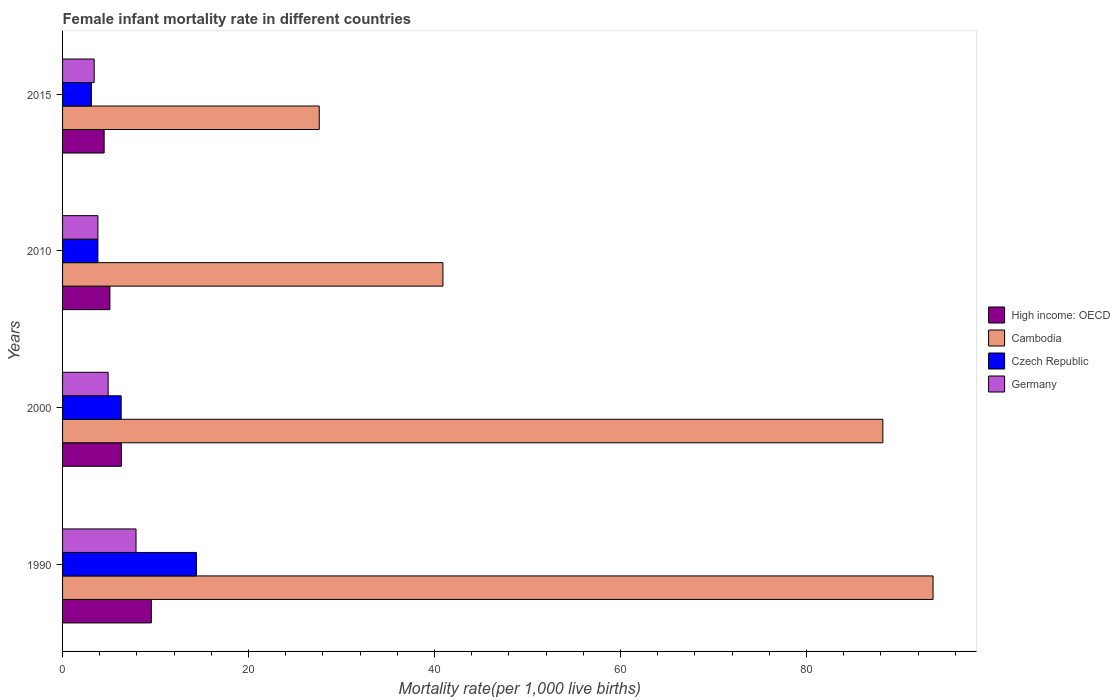How many groups of bars are there?
Your answer should be very brief. 4. Are the number of bars per tick equal to the number of legend labels?
Ensure brevity in your answer.  Yes. How many bars are there on the 4th tick from the top?
Your answer should be very brief. 4. How many bars are there on the 1st tick from the bottom?
Offer a terse response. 4. What is the label of the 1st group of bars from the top?
Provide a short and direct response. 2015. What is the female infant mortality rate in High income: OECD in 1990?
Give a very brief answer. 9.54. Across all years, what is the maximum female infant mortality rate in Cambodia?
Give a very brief answer. 93.6. Across all years, what is the minimum female infant mortality rate in Czech Republic?
Offer a very short reply. 3.1. In which year was the female infant mortality rate in Germany minimum?
Give a very brief answer. 2015. What is the total female infant mortality rate in Germany in the graph?
Give a very brief answer. 20. What is the difference between the female infant mortality rate in Germany in 1990 and that in 2015?
Ensure brevity in your answer.  4.5. What is the difference between the female infant mortality rate in High income: OECD in 2010 and the female infant mortality rate in Germany in 2015?
Your response must be concise. 1.69. What is the average female infant mortality rate in Cambodia per year?
Your answer should be compact. 62.58. In the year 2010, what is the difference between the female infant mortality rate in Cambodia and female infant mortality rate in Czech Republic?
Your answer should be very brief. 37.1. In how many years, is the female infant mortality rate in Czech Republic greater than 92 ?
Your answer should be very brief. 0. What is the ratio of the female infant mortality rate in Cambodia in 1990 to that in 2010?
Provide a succinct answer. 2.29. Is the female infant mortality rate in High income: OECD in 2000 less than that in 2010?
Your response must be concise. No. Is the difference between the female infant mortality rate in Cambodia in 2010 and 2015 greater than the difference between the female infant mortality rate in Czech Republic in 2010 and 2015?
Offer a terse response. Yes. What is the difference between the highest and the second highest female infant mortality rate in Cambodia?
Ensure brevity in your answer.  5.4. Is it the case that in every year, the sum of the female infant mortality rate in High income: OECD and female infant mortality rate in Czech Republic is greater than the sum of female infant mortality rate in Cambodia and female infant mortality rate in Germany?
Your answer should be very brief. Yes. What does the 1st bar from the top in 2010 represents?
Make the answer very short. Germany. What does the 3rd bar from the bottom in 1990 represents?
Your response must be concise. Czech Republic. Is it the case that in every year, the sum of the female infant mortality rate in Germany and female infant mortality rate in Cambodia is greater than the female infant mortality rate in Czech Republic?
Provide a succinct answer. Yes. How many bars are there?
Provide a short and direct response. 16. How many years are there in the graph?
Give a very brief answer. 4. Does the graph contain any zero values?
Provide a short and direct response. No. Does the graph contain grids?
Your answer should be compact. No. Where does the legend appear in the graph?
Your answer should be very brief. Center right. How many legend labels are there?
Provide a succinct answer. 4. How are the legend labels stacked?
Your answer should be compact. Vertical. What is the title of the graph?
Offer a very short reply. Female infant mortality rate in different countries. Does "Zimbabwe" appear as one of the legend labels in the graph?
Your answer should be very brief. No. What is the label or title of the X-axis?
Provide a short and direct response. Mortality rate(per 1,0 live births). What is the Mortality rate(per 1,000 live births) in High income: OECD in 1990?
Make the answer very short. 9.54. What is the Mortality rate(per 1,000 live births) in Cambodia in 1990?
Offer a very short reply. 93.6. What is the Mortality rate(per 1,000 live births) of Czech Republic in 1990?
Provide a succinct answer. 14.4. What is the Mortality rate(per 1,000 live births) of High income: OECD in 2000?
Keep it short and to the point. 6.32. What is the Mortality rate(per 1,000 live births) of Cambodia in 2000?
Your answer should be compact. 88.2. What is the Mortality rate(per 1,000 live births) of Czech Republic in 2000?
Your answer should be compact. 6.3. What is the Mortality rate(per 1,000 live births) of High income: OECD in 2010?
Your response must be concise. 5.09. What is the Mortality rate(per 1,000 live births) in Cambodia in 2010?
Ensure brevity in your answer.  40.9. What is the Mortality rate(per 1,000 live births) of Czech Republic in 2010?
Ensure brevity in your answer.  3.8. What is the Mortality rate(per 1,000 live births) in Germany in 2010?
Ensure brevity in your answer.  3.8. What is the Mortality rate(per 1,000 live births) in High income: OECD in 2015?
Ensure brevity in your answer.  4.47. What is the Mortality rate(per 1,000 live births) in Cambodia in 2015?
Your answer should be very brief. 27.6. What is the Mortality rate(per 1,000 live births) in Czech Republic in 2015?
Provide a succinct answer. 3.1. What is the Mortality rate(per 1,000 live births) in Germany in 2015?
Give a very brief answer. 3.4. Across all years, what is the maximum Mortality rate(per 1,000 live births) in High income: OECD?
Offer a terse response. 9.54. Across all years, what is the maximum Mortality rate(per 1,000 live births) in Cambodia?
Offer a terse response. 93.6. Across all years, what is the maximum Mortality rate(per 1,000 live births) of Czech Republic?
Offer a terse response. 14.4. Across all years, what is the maximum Mortality rate(per 1,000 live births) of Germany?
Ensure brevity in your answer.  7.9. Across all years, what is the minimum Mortality rate(per 1,000 live births) of High income: OECD?
Offer a very short reply. 4.47. Across all years, what is the minimum Mortality rate(per 1,000 live births) in Cambodia?
Your answer should be very brief. 27.6. Across all years, what is the minimum Mortality rate(per 1,000 live births) of Czech Republic?
Keep it short and to the point. 3.1. What is the total Mortality rate(per 1,000 live births) in High income: OECD in the graph?
Make the answer very short. 25.42. What is the total Mortality rate(per 1,000 live births) in Cambodia in the graph?
Offer a very short reply. 250.3. What is the total Mortality rate(per 1,000 live births) of Czech Republic in the graph?
Offer a terse response. 27.6. What is the difference between the Mortality rate(per 1,000 live births) of High income: OECD in 1990 and that in 2000?
Your response must be concise. 3.22. What is the difference between the Mortality rate(per 1,000 live births) in Cambodia in 1990 and that in 2000?
Provide a short and direct response. 5.4. What is the difference between the Mortality rate(per 1,000 live births) of Germany in 1990 and that in 2000?
Offer a terse response. 3. What is the difference between the Mortality rate(per 1,000 live births) of High income: OECD in 1990 and that in 2010?
Your response must be concise. 4.45. What is the difference between the Mortality rate(per 1,000 live births) in Cambodia in 1990 and that in 2010?
Give a very brief answer. 52.7. What is the difference between the Mortality rate(per 1,000 live births) of High income: OECD in 1990 and that in 2015?
Ensure brevity in your answer.  5.07. What is the difference between the Mortality rate(per 1,000 live births) of Cambodia in 1990 and that in 2015?
Keep it short and to the point. 66. What is the difference between the Mortality rate(per 1,000 live births) of Czech Republic in 1990 and that in 2015?
Provide a succinct answer. 11.3. What is the difference between the Mortality rate(per 1,000 live births) of High income: OECD in 2000 and that in 2010?
Provide a succinct answer. 1.23. What is the difference between the Mortality rate(per 1,000 live births) of Cambodia in 2000 and that in 2010?
Give a very brief answer. 47.3. What is the difference between the Mortality rate(per 1,000 live births) of Germany in 2000 and that in 2010?
Make the answer very short. 1.1. What is the difference between the Mortality rate(per 1,000 live births) of High income: OECD in 2000 and that in 2015?
Make the answer very short. 1.85. What is the difference between the Mortality rate(per 1,000 live births) in Cambodia in 2000 and that in 2015?
Provide a short and direct response. 60.6. What is the difference between the Mortality rate(per 1,000 live births) in Czech Republic in 2000 and that in 2015?
Keep it short and to the point. 3.2. What is the difference between the Mortality rate(per 1,000 live births) in High income: OECD in 2010 and that in 2015?
Your response must be concise. 0.62. What is the difference between the Mortality rate(per 1,000 live births) of Germany in 2010 and that in 2015?
Your response must be concise. 0.4. What is the difference between the Mortality rate(per 1,000 live births) of High income: OECD in 1990 and the Mortality rate(per 1,000 live births) of Cambodia in 2000?
Offer a terse response. -78.66. What is the difference between the Mortality rate(per 1,000 live births) in High income: OECD in 1990 and the Mortality rate(per 1,000 live births) in Czech Republic in 2000?
Make the answer very short. 3.24. What is the difference between the Mortality rate(per 1,000 live births) in High income: OECD in 1990 and the Mortality rate(per 1,000 live births) in Germany in 2000?
Your answer should be compact. 4.64. What is the difference between the Mortality rate(per 1,000 live births) in Cambodia in 1990 and the Mortality rate(per 1,000 live births) in Czech Republic in 2000?
Keep it short and to the point. 87.3. What is the difference between the Mortality rate(per 1,000 live births) in Cambodia in 1990 and the Mortality rate(per 1,000 live births) in Germany in 2000?
Your response must be concise. 88.7. What is the difference between the Mortality rate(per 1,000 live births) of High income: OECD in 1990 and the Mortality rate(per 1,000 live births) of Cambodia in 2010?
Give a very brief answer. -31.36. What is the difference between the Mortality rate(per 1,000 live births) in High income: OECD in 1990 and the Mortality rate(per 1,000 live births) in Czech Republic in 2010?
Offer a very short reply. 5.74. What is the difference between the Mortality rate(per 1,000 live births) in High income: OECD in 1990 and the Mortality rate(per 1,000 live births) in Germany in 2010?
Provide a short and direct response. 5.74. What is the difference between the Mortality rate(per 1,000 live births) of Cambodia in 1990 and the Mortality rate(per 1,000 live births) of Czech Republic in 2010?
Give a very brief answer. 89.8. What is the difference between the Mortality rate(per 1,000 live births) of Cambodia in 1990 and the Mortality rate(per 1,000 live births) of Germany in 2010?
Provide a short and direct response. 89.8. What is the difference between the Mortality rate(per 1,000 live births) in High income: OECD in 1990 and the Mortality rate(per 1,000 live births) in Cambodia in 2015?
Provide a short and direct response. -18.06. What is the difference between the Mortality rate(per 1,000 live births) of High income: OECD in 1990 and the Mortality rate(per 1,000 live births) of Czech Republic in 2015?
Your answer should be very brief. 6.44. What is the difference between the Mortality rate(per 1,000 live births) in High income: OECD in 1990 and the Mortality rate(per 1,000 live births) in Germany in 2015?
Your answer should be very brief. 6.14. What is the difference between the Mortality rate(per 1,000 live births) of Cambodia in 1990 and the Mortality rate(per 1,000 live births) of Czech Republic in 2015?
Your answer should be compact. 90.5. What is the difference between the Mortality rate(per 1,000 live births) in Cambodia in 1990 and the Mortality rate(per 1,000 live births) in Germany in 2015?
Make the answer very short. 90.2. What is the difference between the Mortality rate(per 1,000 live births) in High income: OECD in 2000 and the Mortality rate(per 1,000 live births) in Cambodia in 2010?
Make the answer very short. -34.58. What is the difference between the Mortality rate(per 1,000 live births) in High income: OECD in 2000 and the Mortality rate(per 1,000 live births) in Czech Republic in 2010?
Make the answer very short. 2.52. What is the difference between the Mortality rate(per 1,000 live births) of High income: OECD in 2000 and the Mortality rate(per 1,000 live births) of Germany in 2010?
Your answer should be very brief. 2.52. What is the difference between the Mortality rate(per 1,000 live births) in Cambodia in 2000 and the Mortality rate(per 1,000 live births) in Czech Republic in 2010?
Ensure brevity in your answer.  84.4. What is the difference between the Mortality rate(per 1,000 live births) of Cambodia in 2000 and the Mortality rate(per 1,000 live births) of Germany in 2010?
Keep it short and to the point. 84.4. What is the difference between the Mortality rate(per 1,000 live births) in High income: OECD in 2000 and the Mortality rate(per 1,000 live births) in Cambodia in 2015?
Your response must be concise. -21.28. What is the difference between the Mortality rate(per 1,000 live births) in High income: OECD in 2000 and the Mortality rate(per 1,000 live births) in Czech Republic in 2015?
Your answer should be compact. 3.22. What is the difference between the Mortality rate(per 1,000 live births) of High income: OECD in 2000 and the Mortality rate(per 1,000 live births) of Germany in 2015?
Make the answer very short. 2.92. What is the difference between the Mortality rate(per 1,000 live births) of Cambodia in 2000 and the Mortality rate(per 1,000 live births) of Czech Republic in 2015?
Your answer should be compact. 85.1. What is the difference between the Mortality rate(per 1,000 live births) in Cambodia in 2000 and the Mortality rate(per 1,000 live births) in Germany in 2015?
Give a very brief answer. 84.8. What is the difference between the Mortality rate(per 1,000 live births) of Czech Republic in 2000 and the Mortality rate(per 1,000 live births) of Germany in 2015?
Ensure brevity in your answer.  2.9. What is the difference between the Mortality rate(per 1,000 live births) in High income: OECD in 2010 and the Mortality rate(per 1,000 live births) in Cambodia in 2015?
Provide a short and direct response. -22.51. What is the difference between the Mortality rate(per 1,000 live births) in High income: OECD in 2010 and the Mortality rate(per 1,000 live births) in Czech Republic in 2015?
Your answer should be compact. 1.99. What is the difference between the Mortality rate(per 1,000 live births) in High income: OECD in 2010 and the Mortality rate(per 1,000 live births) in Germany in 2015?
Keep it short and to the point. 1.69. What is the difference between the Mortality rate(per 1,000 live births) in Cambodia in 2010 and the Mortality rate(per 1,000 live births) in Czech Republic in 2015?
Offer a very short reply. 37.8. What is the difference between the Mortality rate(per 1,000 live births) in Cambodia in 2010 and the Mortality rate(per 1,000 live births) in Germany in 2015?
Give a very brief answer. 37.5. What is the difference between the Mortality rate(per 1,000 live births) of Czech Republic in 2010 and the Mortality rate(per 1,000 live births) of Germany in 2015?
Your answer should be very brief. 0.4. What is the average Mortality rate(per 1,000 live births) in High income: OECD per year?
Offer a very short reply. 6.36. What is the average Mortality rate(per 1,000 live births) in Cambodia per year?
Your answer should be compact. 62.58. What is the average Mortality rate(per 1,000 live births) of Czech Republic per year?
Provide a succinct answer. 6.9. In the year 1990, what is the difference between the Mortality rate(per 1,000 live births) of High income: OECD and Mortality rate(per 1,000 live births) of Cambodia?
Your answer should be very brief. -84.06. In the year 1990, what is the difference between the Mortality rate(per 1,000 live births) of High income: OECD and Mortality rate(per 1,000 live births) of Czech Republic?
Your answer should be compact. -4.86. In the year 1990, what is the difference between the Mortality rate(per 1,000 live births) of High income: OECD and Mortality rate(per 1,000 live births) of Germany?
Provide a succinct answer. 1.64. In the year 1990, what is the difference between the Mortality rate(per 1,000 live births) in Cambodia and Mortality rate(per 1,000 live births) in Czech Republic?
Your answer should be compact. 79.2. In the year 1990, what is the difference between the Mortality rate(per 1,000 live births) in Cambodia and Mortality rate(per 1,000 live births) in Germany?
Ensure brevity in your answer.  85.7. In the year 2000, what is the difference between the Mortality rate(per 1,000 live births) in High income: OECD and Mortality rate(per 1,000 live births) in Cambodia?
Provide a short and direct response. -81.88. In the year 2000, what is the difference between the Mortality rate(per 1,000 live births) of High income: OECD and Mortality rate(per 1,000 live births) of Czech Republic?
Make the answer very short. 0.02. In the year 2000, what is the difference between the Mortality rate(per 1,000 live births) in High income: OECD and Mortality rate(per 1,000 live births) in Germany?
Keep it short and to the point. 1.42. In the year 2000, what is the difference between the Mortality rate(per 1,000 live births) in Cambodia and Mortality rate(per 1,000 live births) in Czech Republic?
Ensure brevity in your answer.  81.9. In the year 2000, what is the difference between the Mortality rate(per 1,000 live births) in Cambodia and Mortality rate(per 1,000 live births) in Germany?
Give a very brief answer. 83.3. In the year 2000, what is the difference between the Mortality rate(per 1,000 live births) of Czech Republic and Mortality rate(per 1,000 live births) of Germany?
Your answer should be very brief. 1.4. In the year 2010, what is the difference between the Mortality rate(per 1,000 live births) in High income: OECD and Mortality rate(per 1,000 live births) in Cambodia?
Ensure brevity in your answer.  -35.81. In the year 2010, what is the difference between the Mortality rate(per 1,000 live births) of High income: OECD and Mortality rate(per 1,000 live births) of Czech Republic?
Your answer should be compact. 1.29. In the year 2010, what is the difference between the Mortality rate(per 1,000 live births) of High income: OECD and Mortality rate(per 1,000 live births) of Germany?
Offer a very short reply. 1.29. In the year 2010, what is the difference between the Mortality rate(per 1,000 live births) in Cambodia and Mortality rate(per 1,000 live births) in Czech Republic?
Provide a short and direct response. 37.1. In the year 2010, what is the difference between the Mortality rate(per 1,000 live births) in Cambodia and Mortality rate(per 1,000 live births) in Germany?
Your response must be concise. 37.1. In the year 2010, what is the difference between the Mortality rate(per 1,000 live births) of Czech Republic and Mortality rate(per 1,000 live births) of Germany?
Your answer should be compact. 0. In the year 2015, what is the difference between the Mortality rate(per 1,000 live births) in High income: OECD and Mortality rate(per 1,000 live births) in Cambodia?
Make the answer very short. -23.13. In the year 2015, what is the difference between the Mortality rate(per 1,000 live births) in High income: OECD and Mortality rate(per 1,000 live births) in Czech Republic?
Give a very brief answer. 1.37. In the year 2015, what is the difference between the Mortality rate(per 1,000 live births) in High income: OECD and Mortality rate(per 1,000 live births) in Germany?
Provide a succinct answer. 1.07. In the year 2015, what is the difference between the Mortality rate(per 1,000 live births) of Cambodia and Mortality rate(per 1,000 live births) of Germany?
Offer a terse response. 24.2. What is the ratio of the Mortality rate(per 1,000 live births) in High income: OECD in 1990 to that in 2000?
Your answer should be very brief. 1.51. What is the ratio of the Mortality rate(per 1,000 live births) in Cambodia in 1990 to that in 2000?
Ensure brevity in your answer.  1.06. What is the ratio of the Mortality rate(per 1,000 live births) of Czech Republic in 1990 to that in 2000?
Your response must be concise. 2.29. What is the ratio of the Mortality rate(per 1,000 live births) in Germany in 1990 to that in 2000?
Provide a succinct answer. 1.61. What is the ratio of the Mortality rate(per 1,000 live births) in High income: OECD in 1990 to that in 2010?
Give a very brief answer. 1.88. What is the ratio of the Mortality rate(per 1,000 live births) in Cambodia in 1990 to that in 2010?
Your answer should be very brief. 2.29. What is the ratio of the Mortality rate(per 1,000 live births) of Czech Republic in 1990 to that in 2010?
Offer a very short reply. 3.79. What is the ratio of the Mortality rate(per 1,000 live births) of Germany in 1990 to that in 2010?
Offer a very short reply. 2.08. What is the ratio of the Mortality rate(per 1,000 live births) of High income: OECD in 1990 to that in 2015?
Keep it short and to the point. 2.13. What is the ratio of the Mortality rate(per 1,000 live births) in Cambodia in 1990 to that in 2015?
Provide a succinct answer. 3.39. What is the ratio of the Mortality rate(per 1,000 live births) in Czech Republic in 1990 to that in 2015?
Offer a very short reply. 4.65. What is the ratio of the Mortality rate(per 1,000 live births) in Germany in 1990 to that in 2015?
Give a very brief answer. 2.32. What is the ratio of the Mortality rate(per 1,000 live births) of High income: OECD in 2000 to that in 2010?
Make the answer very short. 1.24. What is the ratio of the Mortality rate(per 1,000 live births) of Cambodia in 2000 to that in 2010?
Your answer should be compact. 2.16. What is the ratio of the Mortality rate(per 1,000 live births) in Czech Republic in 2000 to that in 2010?
Provide a short and direct response. 1.66. What is the ratio of the Mortality rate(per 1,000 live births) of Germany in 2000 to that in 2010?
Provide a short and direct response. 1.29. What is the ratio of the Mortality rate(per 1,000 live births) in High income: OECD in 2000 to that in 2015?
Provide a short and direct response. 1.41. What is the ratio of the Mortality rate(per 1,000 live births) in Cambodia in 2000 to that in 2015?
Your answer should be compact. 3.2. What is the ratio of the Mortality rate(per 1,000 live births) in Czech Republic in 2000 to that in 2015?
Keep it short and to the point. 2.03. What is the ratio of the Mortality rate(per 1,000 live births) of Germany in 2000 to that in 2015?
Offer a terse response. 1.44. What is the ratio of the Mortality rate(per 1,000 live births) of High income: OECD in 2010 to that in 2015?
Give a very brief answer. 1.14. What is the ratio of the Mortality rate(per 1,000 live births) of Cambodia in 2010 to that in 2015?
Your response must be concise. 1.48. What is the ratio of the Mortality rate(per 1,000 live births) in Czech Republic in 2010 to that in 2015?
Give a very brief answer. 1.23. What is the ratio of the Mortality rate(per 1,000 live births) of Germany in 2010 to that in 2015?
Keep it short and to the point. 1.12. What is the difference between the highest and the second highest Mortality rate(per 1,000 live births) of High income: OECD?
Ensure brevity in your answer.  3.22. What is the difference between the highest and the second highest Mortality rate(per 1,000 live births) of Germany?
Provide a succinct answer. 3. What is the difference between the highest and the lowest Mortality rate(per 1,000 live births) of High income: OECD?
Ensure brevity in your answer.  5.07. 